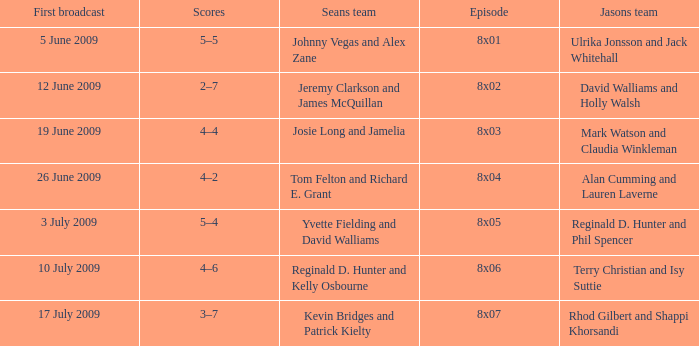What is the broadcast date where Jason's team is Rhod Gilbert and Shappi Khorsandi? 17 July 2009. 